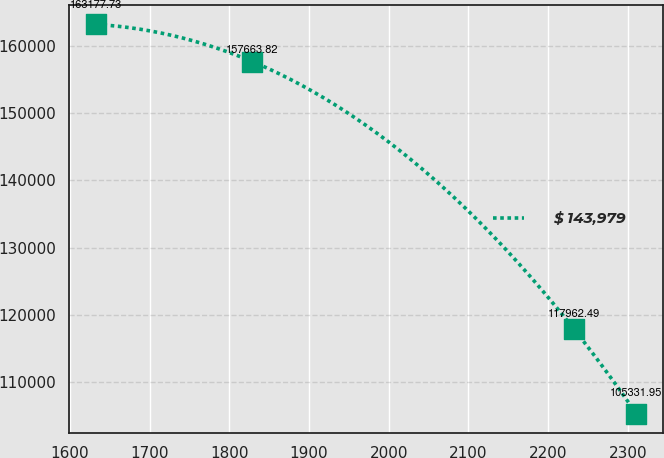<chart> <loc_0><loc_0><loc_500><loc_500><line_chart><ecel><fcel>$ 143,979<nl><fcel>1633.2<fcel>163178<nl><fcel>1828.92<fcel>157664<nl><fcel>2232.14<fcel>117962<nl><fcel>2310.9<fcel>105332<nl></chart> 